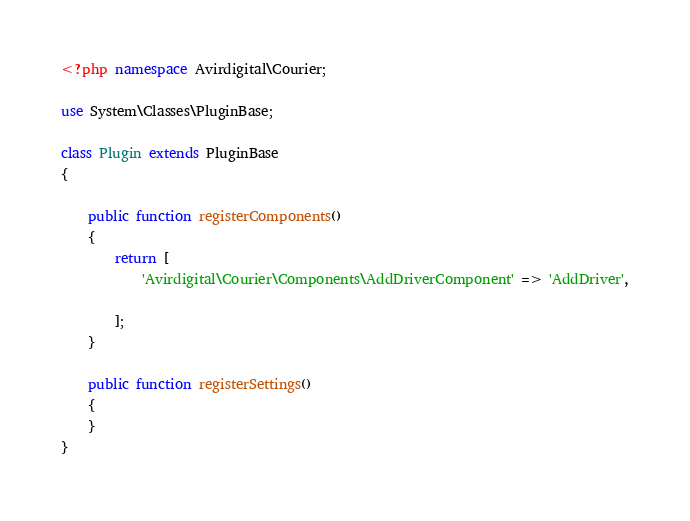Convert code to text. <code><loc_0><loc_0><loc_500><loc_500><_PHP_><?php namespace Avirdigital\Courier;

use System\Classes\PluginBase;

class Plugin extends PluginBase
{

    public function registerComponents()
    {
        return [
            'Avirdigital\Courier\Components\AddDriverComponent' => 'AddDriver',

        ];
    }

    public function registerSettings()
    {
    }
}
</code> 